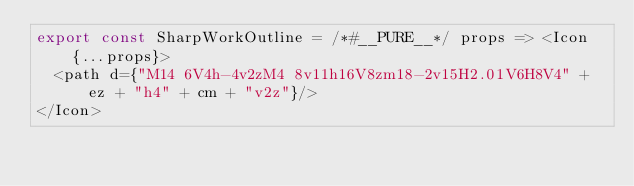Convert code to text. <code><loc_0><loc_0><loc_500><loc_500><_JavaScript_>export const SharpWorkOutline = /*#__PURE__*/ props => <Icon {...props}>
  <path d={"M14 6V4h-4v2zM4 8v11h16V8zm18-2v15H2.01V6H8V4" + ez + "h4" + cm + "v2z"}/>
</Icon>
</code> 